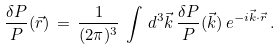Convert formula to latex. <formula><loc_0><loc_0><loc_500><loc_500>\frac { \delta P } { P } ( \vec { r } ) \, = \, \frac { 1 } { ( 2 \pi ) ^ { 3 } } \, \int \, d ^ { 3 } \vec { k } \, \frac { \delta P } { P } ( \vec { k } ) \, e ^ { - i \vec { k } \cdot \vec { r } } \, .</formula> 